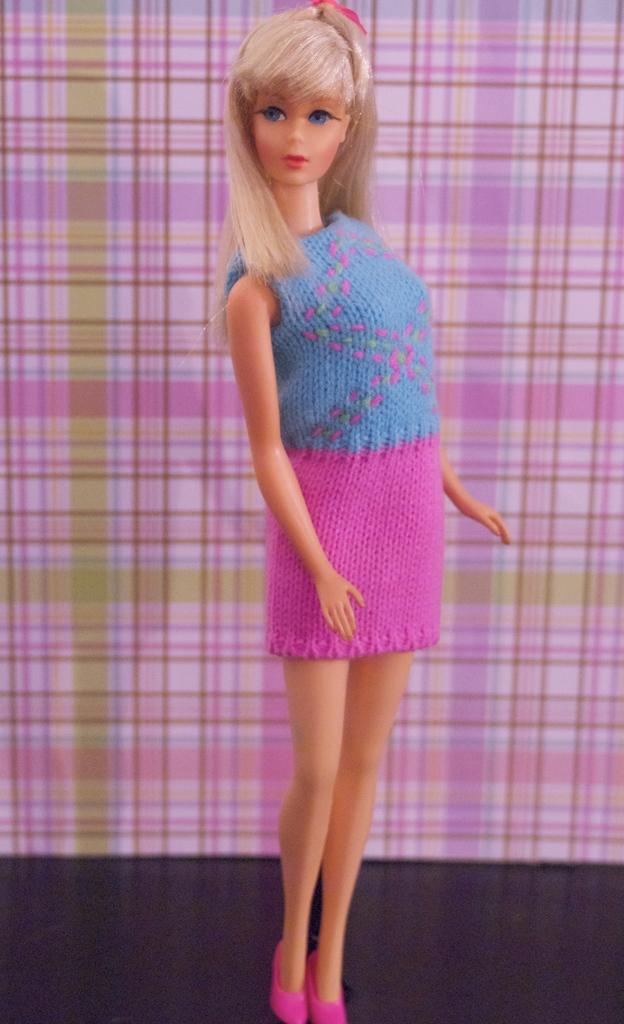What type of doll is in the image? There is a Barbie doll in the image. Where is the Barbie doll positioned in the image? The Barbie doll is standing on the floor. What color is the floor in the image? The floor is black. What can be seen in the image besides the Barbie doll? There is a pink and green cloth in the image. What type of secretary is sitting behind the desk in the image? There is no secretary or desk present in the image; it features a Barbie doll standing on a black floor with a pink and green cloth. 